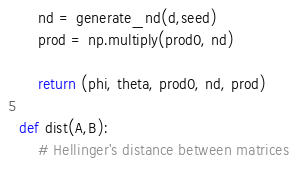Convert code to text. <code><loc_0><loc_0><loc_500><loc_500><_Python_>    nd = generate_nd(d,seed)
    prod = np.multiply(prod0, nd)

    return (phi, theta, prod0, nd, prod)

def dist(A,B):
    # Hellinger's distance between matrices</code> 